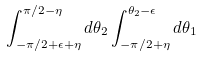Convert formula to latex. <formula><loc_0><loc_0><loc_500><loc_500>\int _ { - \pi / 2 + \epsilon + \eta } ^ { \pi / 2 - \eta } d \theta _ { 2 } \int _ { - \pi / 2 + \eta } ^ { \theta _ { 2 } - \epsilon } d \theta _ { 1 }</formula> 